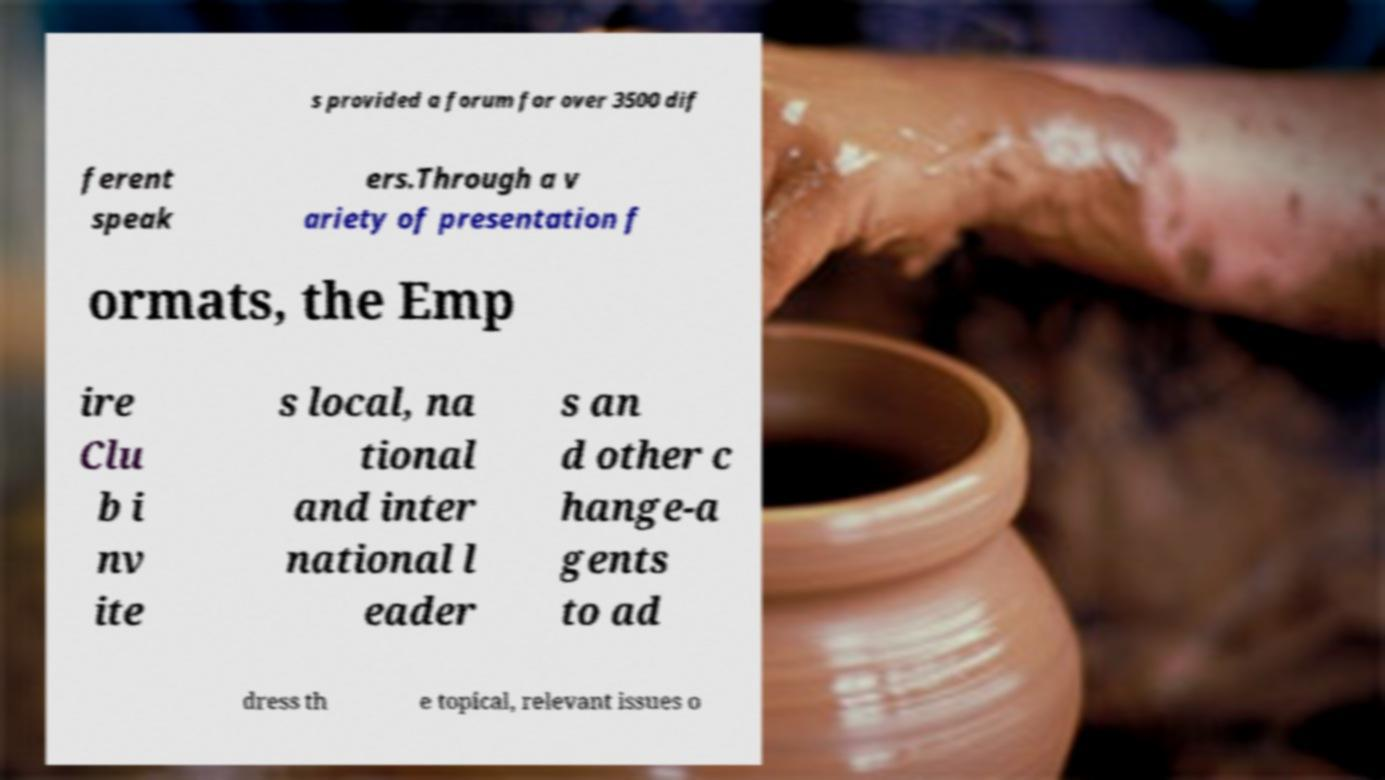Please read and relay the text visible in this image. What does it say? s provided a forum for over 3500 dif ferent speak ers.Through a v ariety of presentation f ormats, the Emp ire Clu b i nv ite s local, na tional and inter national l eader s an d other c hange-a gents to ad dress th e topical, relevant issues o 